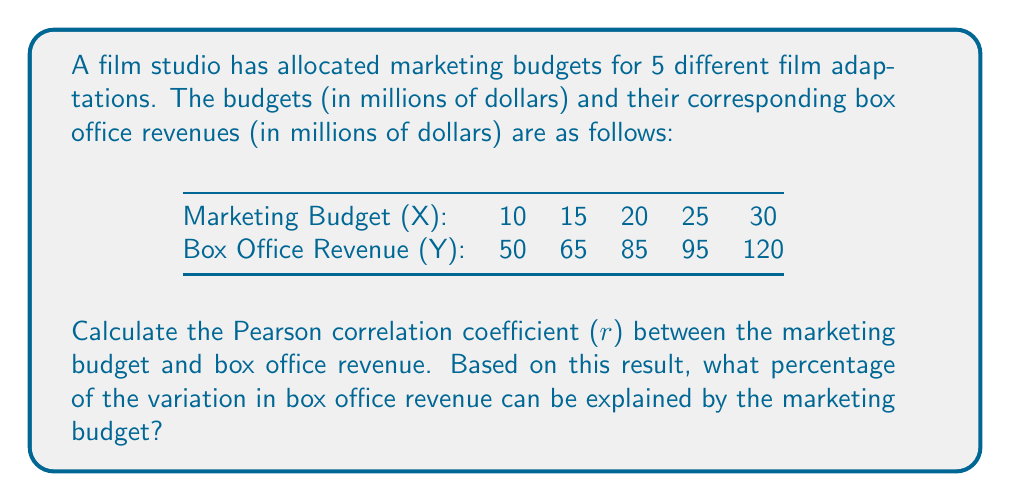Solve this math problem. To solve this problem, we'll follow these steps:

1. Calculate the Pearson correlation coefficient (r)
2. Calculate the coefficient of determination (r²)
3. Convert r² to a percentage

Step 1: Calculate the Pearson correlation coefficient (r)

The formula for r is:

$$ r = \frac{n\sum xy - (\sum x)(\sum y)}{\sqrt{[n\sum x^2 - (\sum x)^2][n\sum y^2 - (\sum y)^2]}} $$

Where:
n = number of pairs of data
x = marketing budget
y = box office revenue

First, let's calculate the required sums:

$\sum x = 100$
$\sum y = 415$
$\sum xy = 8,775$
$\sum x^2 = 2,250$
$\sum y^2 = 37,175$

Now, let's substitute these values into the formula:

$$ r = \frac{5(8,775) - (100)(415)}{\sqrt{[5(2,250) - (100)^2][5(37,175) - (415)^2]}} $$

$$ r = \frac{43,875 - 41,500}{\sqrt{(11,250 - 10,000)(185,875 - 172,225)}} $$

$$ r = \frac{2,375}{\sqrt{(1,250)(13,650)}} = \frac{2,375}{\sqrt{17,062,500}} = \frac{2,375}{4,130.67} $$

$$ r \approx 0.9757 $$

Step 2: Calculate the coefficient of determination (r²)

$$ r^2 = (0.9757)^2 \approx 0.9520 $$

Step 3: Convert r² to a percentage

$$ 0.9520 \times 100\% = 95.20\% $$

Therefore, approximately 95.20% of the variation in box office revenue can be explained by the marketing budget.
Answer: 95.20% 